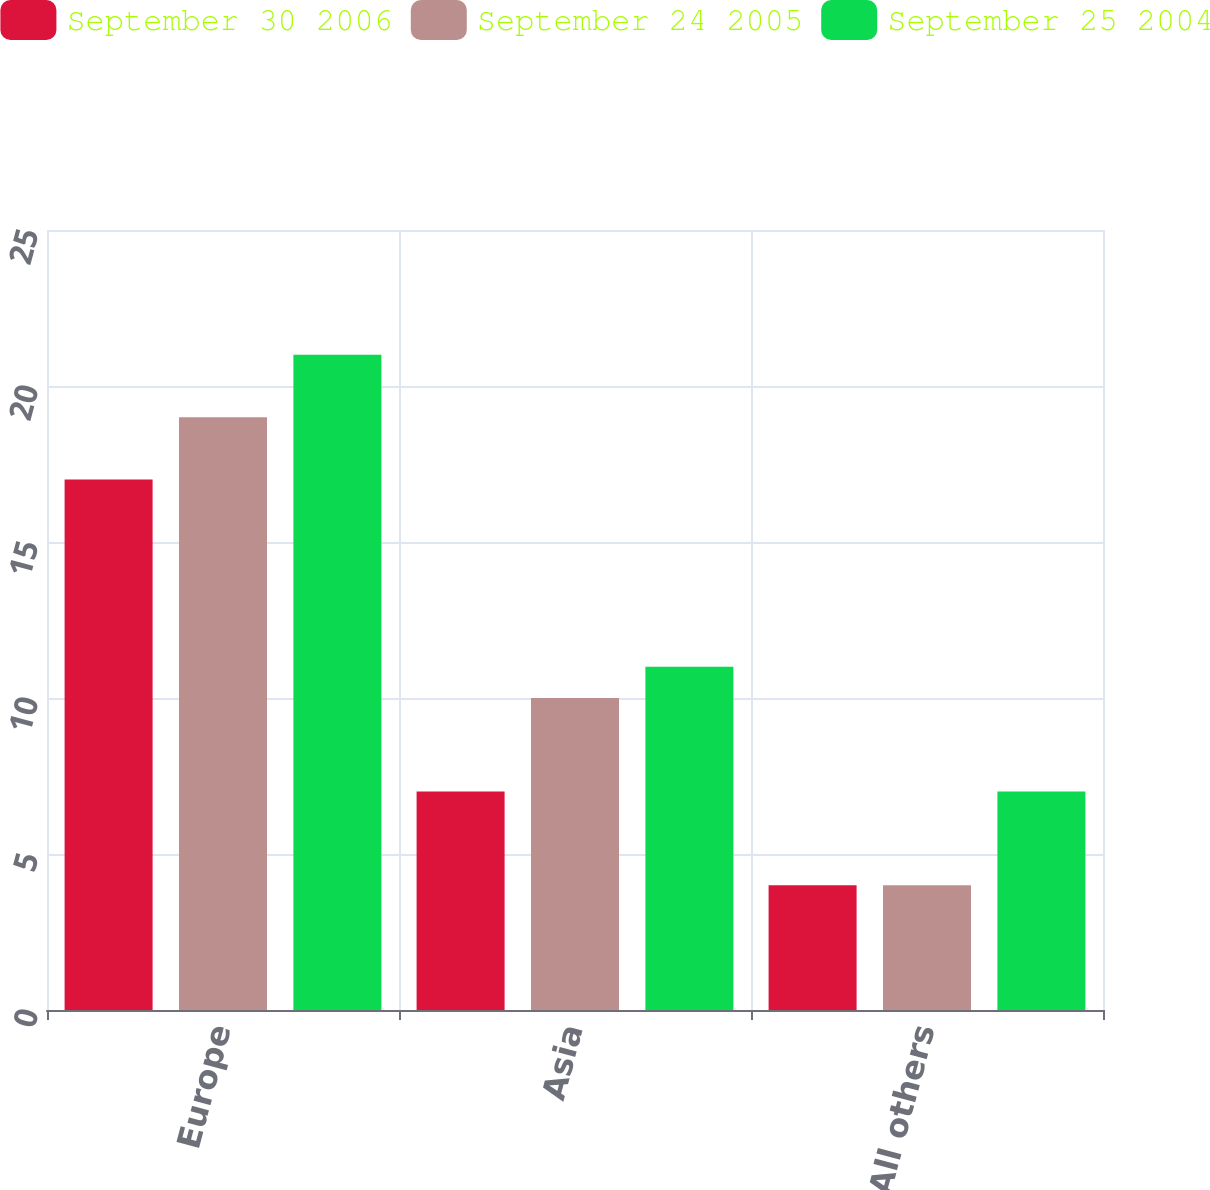Convert chart to OTSL. <chart><loc_0><loc_0><loc_500><loc_500><stacked_bar_chart><ecel><fcel>Europe<fcel>Asia<fcel>All others<nl><fcel>September 30 2006<fcel>17<fcel>7<fcel>4<nl><fcel>September 24 2005<fcel>19<fcel>10<fcel>4<nl><fcel>September 25 2004<fcel>21<fcel>11<fcel>7<nl></chart> 